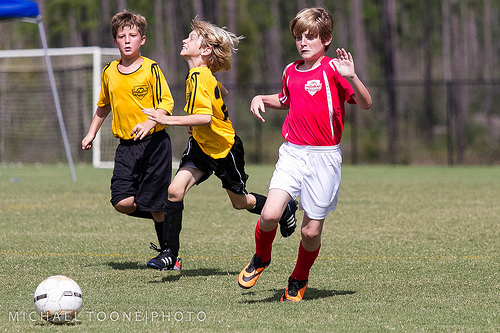<image>
Can you confirm if the ball is next to the boy? No. The ball is not positioned next to the boy. They are located in different areas of the scene. 